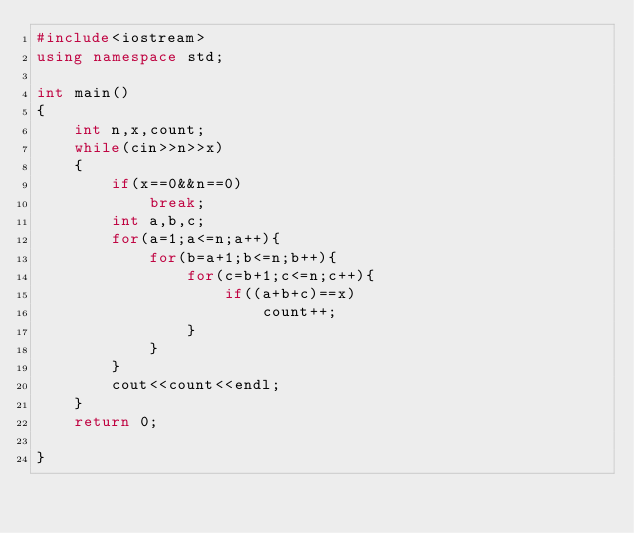<code> <loc_0><loc_0><loc_500><loc_500><_C++_>#include<iostream>
using namespace std;

int main()
{
    int n,x,count;
    while(cin>>n>>x)
    {
        if(x==0&&n==0)
            break;
        int a,b,c;
        for(a=1;a<=n;a++){
            for(b=a+1;b<=n;b++){
                for(c=b+1;c<=n;c++){
                    if((a+b+c)==x)
                        count++;
                }
            }
        }
        cout<<count<<endl;
    }
    return 0;

}</code> 